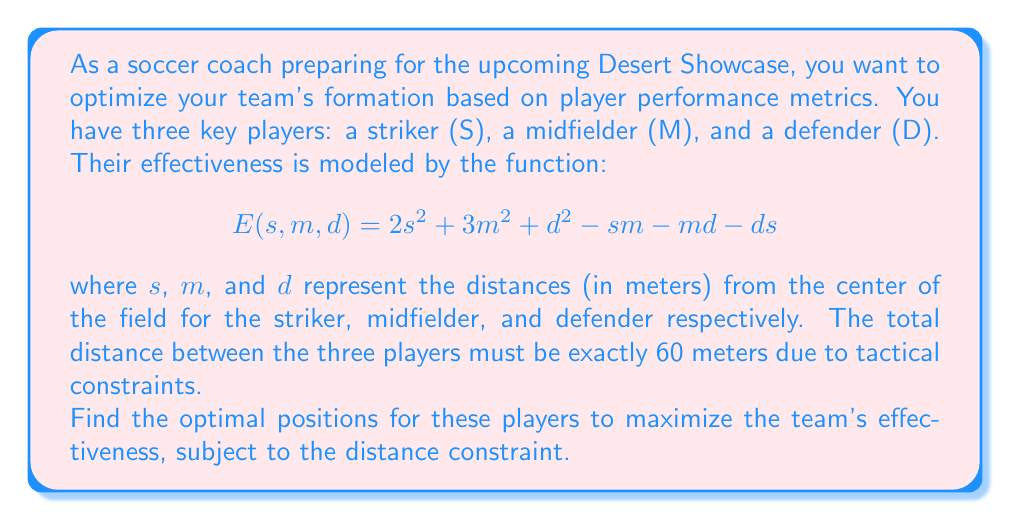Help me with this question. To solve this optimization problem with a constraint, we'll use the method of Lagrange multipliers.

1) First, let's define our constraint function:
   $$g(s, m, d) = s + m + d - 60 = 0$$

2) Now, we form the Lagrangian function:
   $$L(s, m, d, λ) = E(s, m, d) - λg(s, m, d)$$
   $$L(s, m, d, λ) = 2s^2 + 3m^2 + d^2 - sm - md - ds - λ(s + m + d - 60)$$

3) We find the partial derivatives and set them to zero:
   $$\frac{\partial L}{\partial s} = 4s - m - d - λ = 0$$
   $$\frac{\partial L}{\partial m} = 6m - s - d - λ = 0$$
   $$\frac{\partial L}{\partial d} = 2d - s - m - λ = 0$$
   $$\frac{\partial L}{\partial λ} = -(s + m + d - 60) = 0$$

4) From the last equation, we confirm our constraint: $s + m + d = 60$

5) Subtracting the third equation from the first:
   $$4s - m - d - (2d - s - m) = 0$$
   $$5s - 3d = 0$$
   $$s = \frac{3}{5}d$$

6) Subtracting the third equation from the second:
   $$6m - s - d - (2d - s - m) = 0$$
   $$7m - 3d = 0$$
   $$m = \frac{3}{7}d$$

7) Substituting these into our constraint equation:
   $$\frac{3}{5}d + \frac{3}{7}d + d = 60$$
   $$(\frac{21}{35} + \frac{15}{35} + \frac{35}{35})d = 60$$
   $$\frac{71}{35}d = 60$$
   $$d = \frac{60 * 35}{71} \approx 29.58$$

8) Now we can solve for $s$ and $m$:
   $$s = \frac{3}{5} * 29.58 \approx 17.75$$
   $$m = \frac{3}{7} * 29.58 \approx 12.67$$

9) To confirm this is a maximum, we would need to check the second partial derivatives, but given the problem context, this solution is likely to be the maximum.
Answer: The optimal positions (in meters from the center of the field) are:
Striker (S): 17.75 m
Midfielder (M): 12.67 m
Defender (D): 29.58 m 